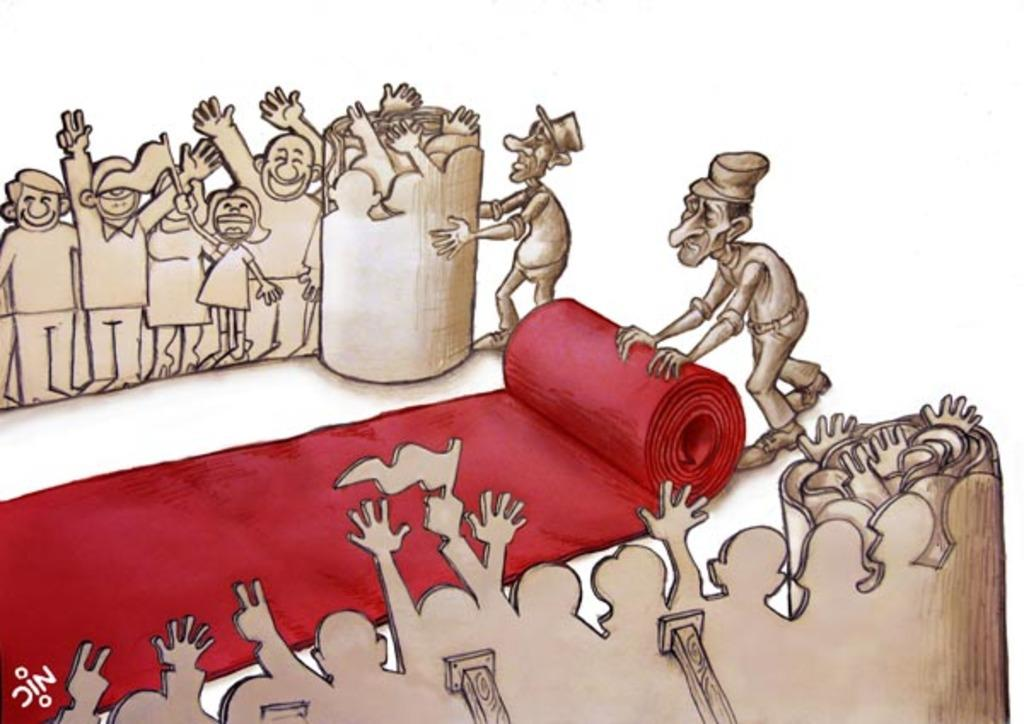What type of artwork is depicted in the image? The image is a drawing. How many people are in the drawing? There are many persons in the drawing. What is in the middle of the drawing? There is a red carpet in the middle of the drawing. What material are the persons in the drawing made of? The persons in the drawing are made up of cardboard. Can you see any squirrels running on the grain in the image? There are no squirrels or grain present in the image; it features a drawing of many persons and a red carpet. 